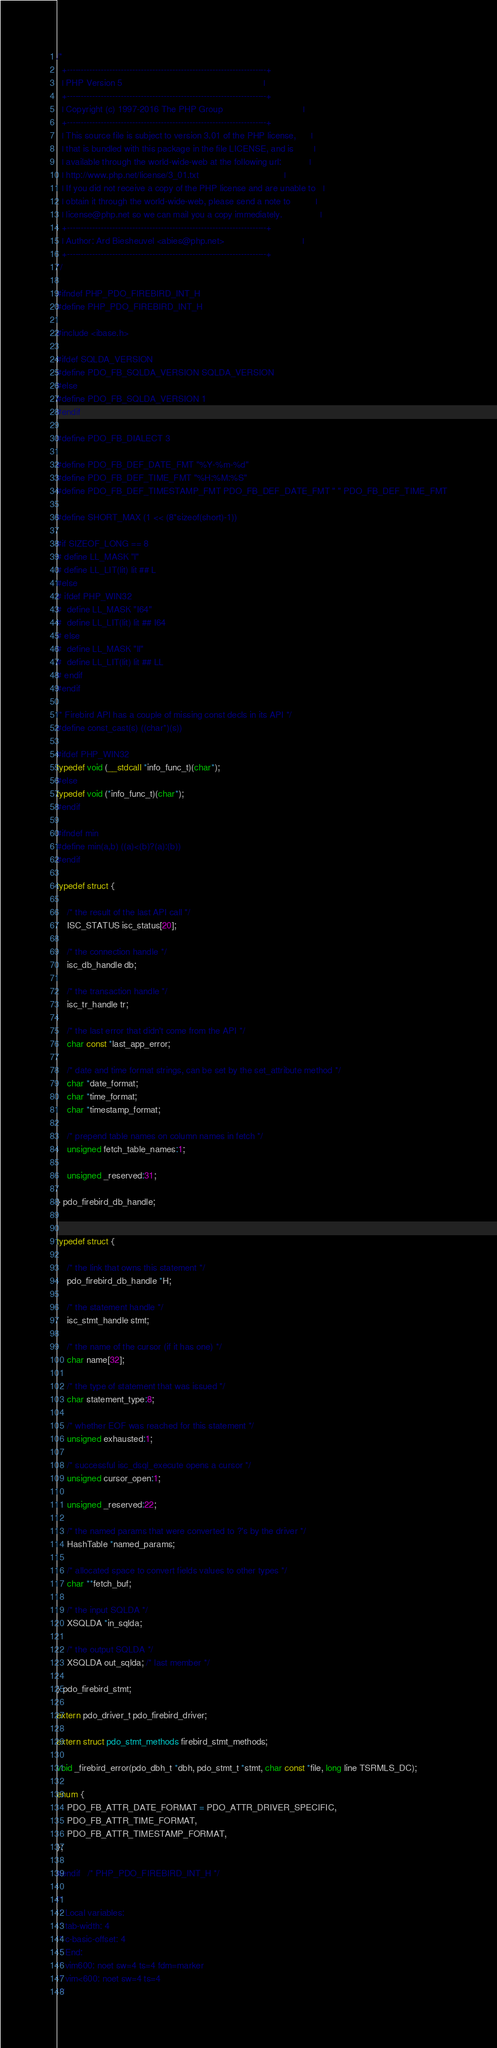<code> <loc_0><loc_0><loc_500><loc_500><_C_>/*
  +----------------------------------------------------------------------+
  | PHP Version 5                                                        |
  +----------------------------------------------------------------------+
  | Copyright (c) 1997-2016 The PHP Group                                |
  +----------------------------------------------------------------------+
  | This source file is subject to version 3.01 of the PHP license,      |
  | that is bundled with this package in the file LICENSE, and is        |
  | available through the world-wide-web at the following url:           |
  | http://www.php.net/license/3_01.txt                                  |
  | If you did not receive a copy of the PHP license and are unable to   |
  | obtain it through the world-wide-web, please send a note to          |
  | license@php.net so we can mail you a copy immediately.               |
  +----------------------------------------------------------------------+
  | Author: Ard Biesheuvel <abies@php.net>                               |
  +----------------------------------------------------------------------+
*/

#ifndef PHP_PDO_FIREBIRD_INT_H
#define PHP_PDO_FIREBIRD_INT_H

#include <ibase.h>

#ifdef SQLDA_VERSION
#define PDO_FB_SQLDA_VERSION SQLDA_VERSION
#else
#define PDO_FB_SQLDA_VERSION 1
#endif

#define PDO_FB_DIALECT 3

#define PDO_FB_DEF_DATE_FMT "%Y-%m-%d"
#define PDO_FB_DEF_TIME_FMT "%H:%M:%S"
#define PDO_FB_DEF_TIMESTAMP_FMT PDO_FB_DEF_DATE_FMT " " PDO_FB_DEF_TIME_FMT

#define SHORT_MAX (1 << (8*sizeof(short)-1))

#if SIZEOF_LONG == 8
# define LL_MASK "l"
# define LL_LIT(lit) lit ## L
#else
# ifdef PHP_WIN32
#  define LL_MASK "I64"
#  define LL_LIT(lit) lit ## I64
# else
#  define LL_MASK "ll"
#  define LL_LIT(lit) lit ## LL
# endif
#endif

/* Firebird API has a couple of missing const decls in its API */
#define const_cast(s) ((char*)(s))

#ifdef PHP_WIN32
typedef void (__stdcall *info_func_t)(char*);
#else
typedef void (*info_func_t)(char*);
#endif

#ifndef min
#define min(a,b) ((a)<(b)?(a):(b))
#endif

typedef struct {

	/* the result of the last API call */
	ISC_STATUS isc_status[20];

	/* the connection handle */
	isc_db_handle db;

	/* the transaction handle */
	isc_tr_handle tr;

	/* the last error that didn't come from the API */
	char const *last_app_error;
	
	/* date and time format strings, can be set by the set_attribute method */
	char *date_format;
	char *time_format;
	char *timestamp_format;
	
	/* prepend table names on column names in fetch */
	unsigned fetch_table_names:1;
	
	unsigned _reserved:31;
	
} pdo_firebird_db_handle;


typedef struct {
	
	/* the link that owns this statement */
	pdo_firebird_db_handle *H;
	
	/* the statement handle */
	isc_stmt_handle stmt;
	
	/* the name of the cursor (if it has one) */
	char name[32];
	
	/* the type of statement that was issued */
	char statement_type:8;
	
	/* whether EOF was reached for this statement */
	unsigned exhausted:1;

	/* successful isc_dsql_execute opens a cursor */
	unsigned cursor_open:1;

	unsigned _reserved:22;

	/* the named params that were converted to ?'s by the driver */
	HashTable *named_params;
	
	/* allocated space to convert fields values to other types */
	char **fetch_buf;
	
	/* the input SQLDA */
	XSQLDA *in_sqlda;
	
	/* the output SQLDA */
	XSQLDA out_sqlda; /* last member */
	
} pdo_firebird_stmt;

extern pdo_driver_t pdo_firebird_driver;

extern struct pdo_stmt_methods firebird_stmt_methods;

void _firebird_error(pdo_dbh_t *dbh, pdo_stmt_t *stmt, char const *file, long line TSRMLS_DC);

enum {
	PDO_FB_ATTR_DATE_FORMAT = PDO_ATTR_DRIVER_SPECIFIC,
	PDO_FB_ATTR_TIME_FORMAT,
	PDO_FB_ATTR_TIMESTAMP_FORMAT,
};

#endif	/* PHP_PDO_FIREBIRD_INT_H */

/*
 * Local variables:
 * tab-width: 4
 * c-basic-offset: 4
 * End:
 * vim600: noet sw=4 ts=4 fdm=marker
 * vim<600: noet sw=4 ts=4
 */
</code> 